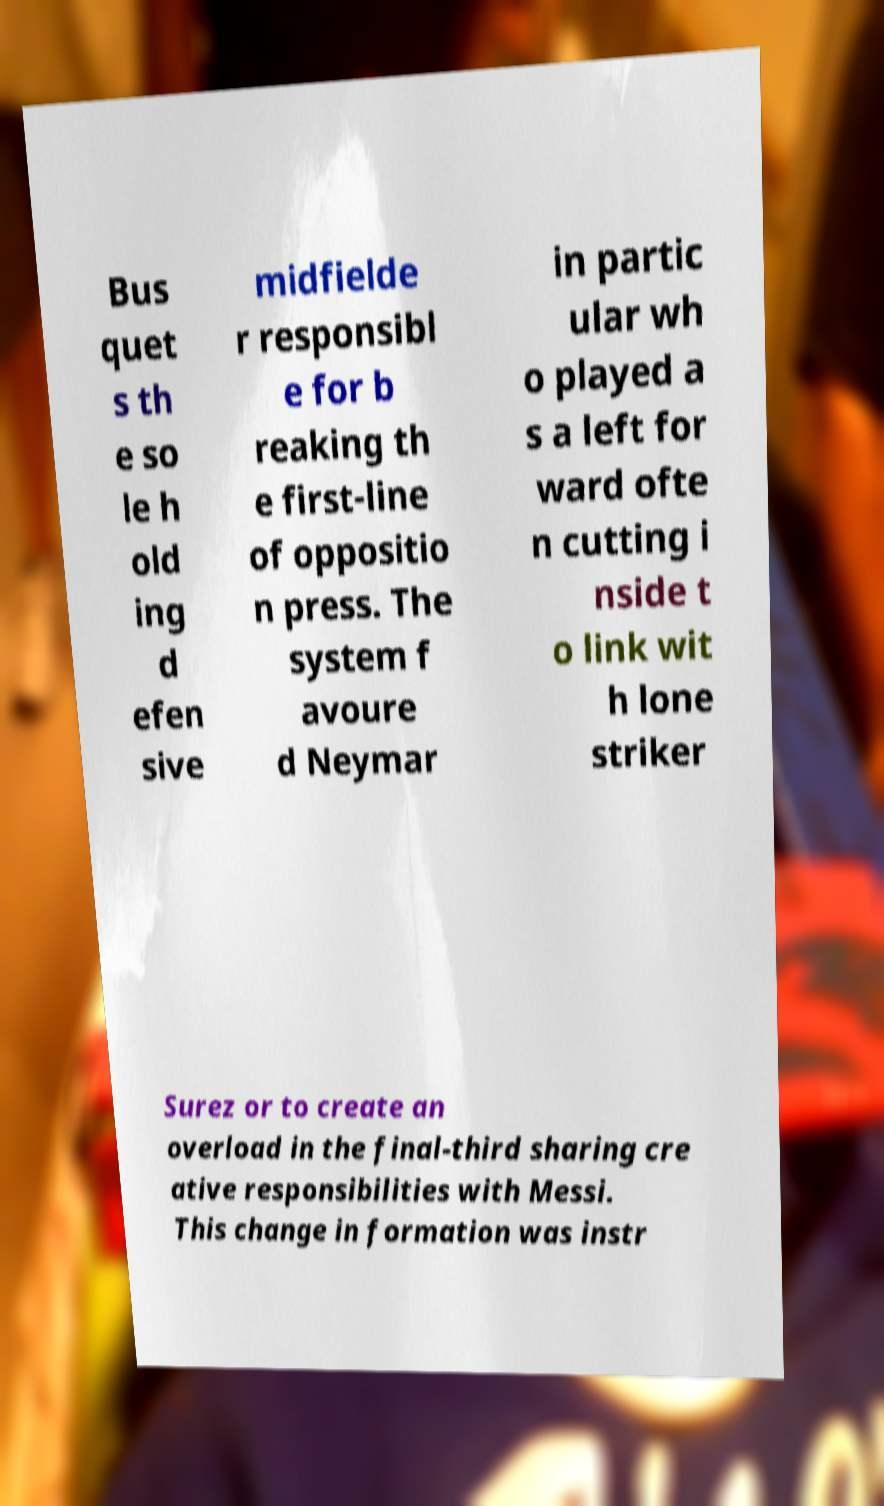Please read and relay the text visible in this image. What does it say? Bus quet s th e so le h old ing d efen sive midfielde r responsibl e for b reaking th e first-line of oppositio n press. The system f avoure d Neymar in partic ular wh o played a s a left for ward ofte n cutting i nside t o link wit h lone striker Surez or to create an overload in the final-third sharing cre ative responsibilities with Messi. This change in formation was instr 